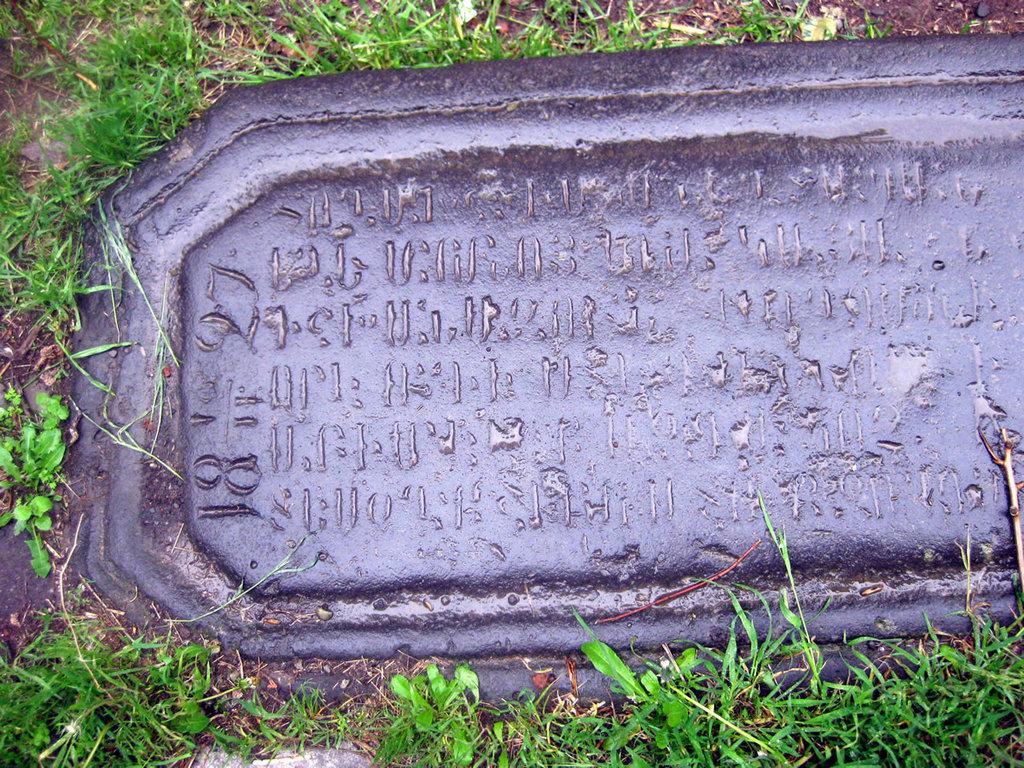Describe this image in one or two sentences. In this picture there is a stone and there is text on the stone and there's grass on the ground. 